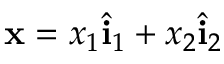<formula> <loc_0><loc_0><loc_500><loc_500>{ x } = x _ { 1 } \hat { i } _ { 1 } + x _ { 2 } \hat { i } _ { 2 }</formula> 